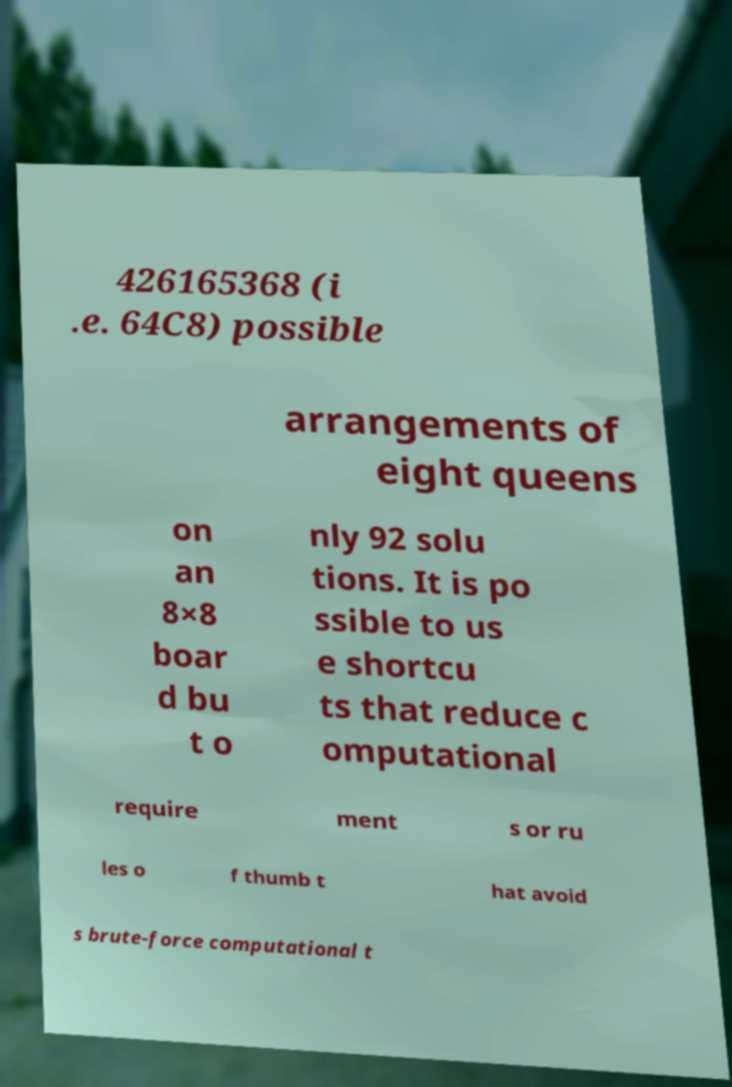There's text embedded in this image that I need extracted. Can you transcribe it verbatim? 426165368 (i .e. 64C8) possible arrangements of eight queens on an 8×8 boar d bu t o nly 92 solu tions. It is po ssible to us e shortcu ts that reduce c omputational require ment s or ru les o f thumb t hat avoid s brute-force computational t 